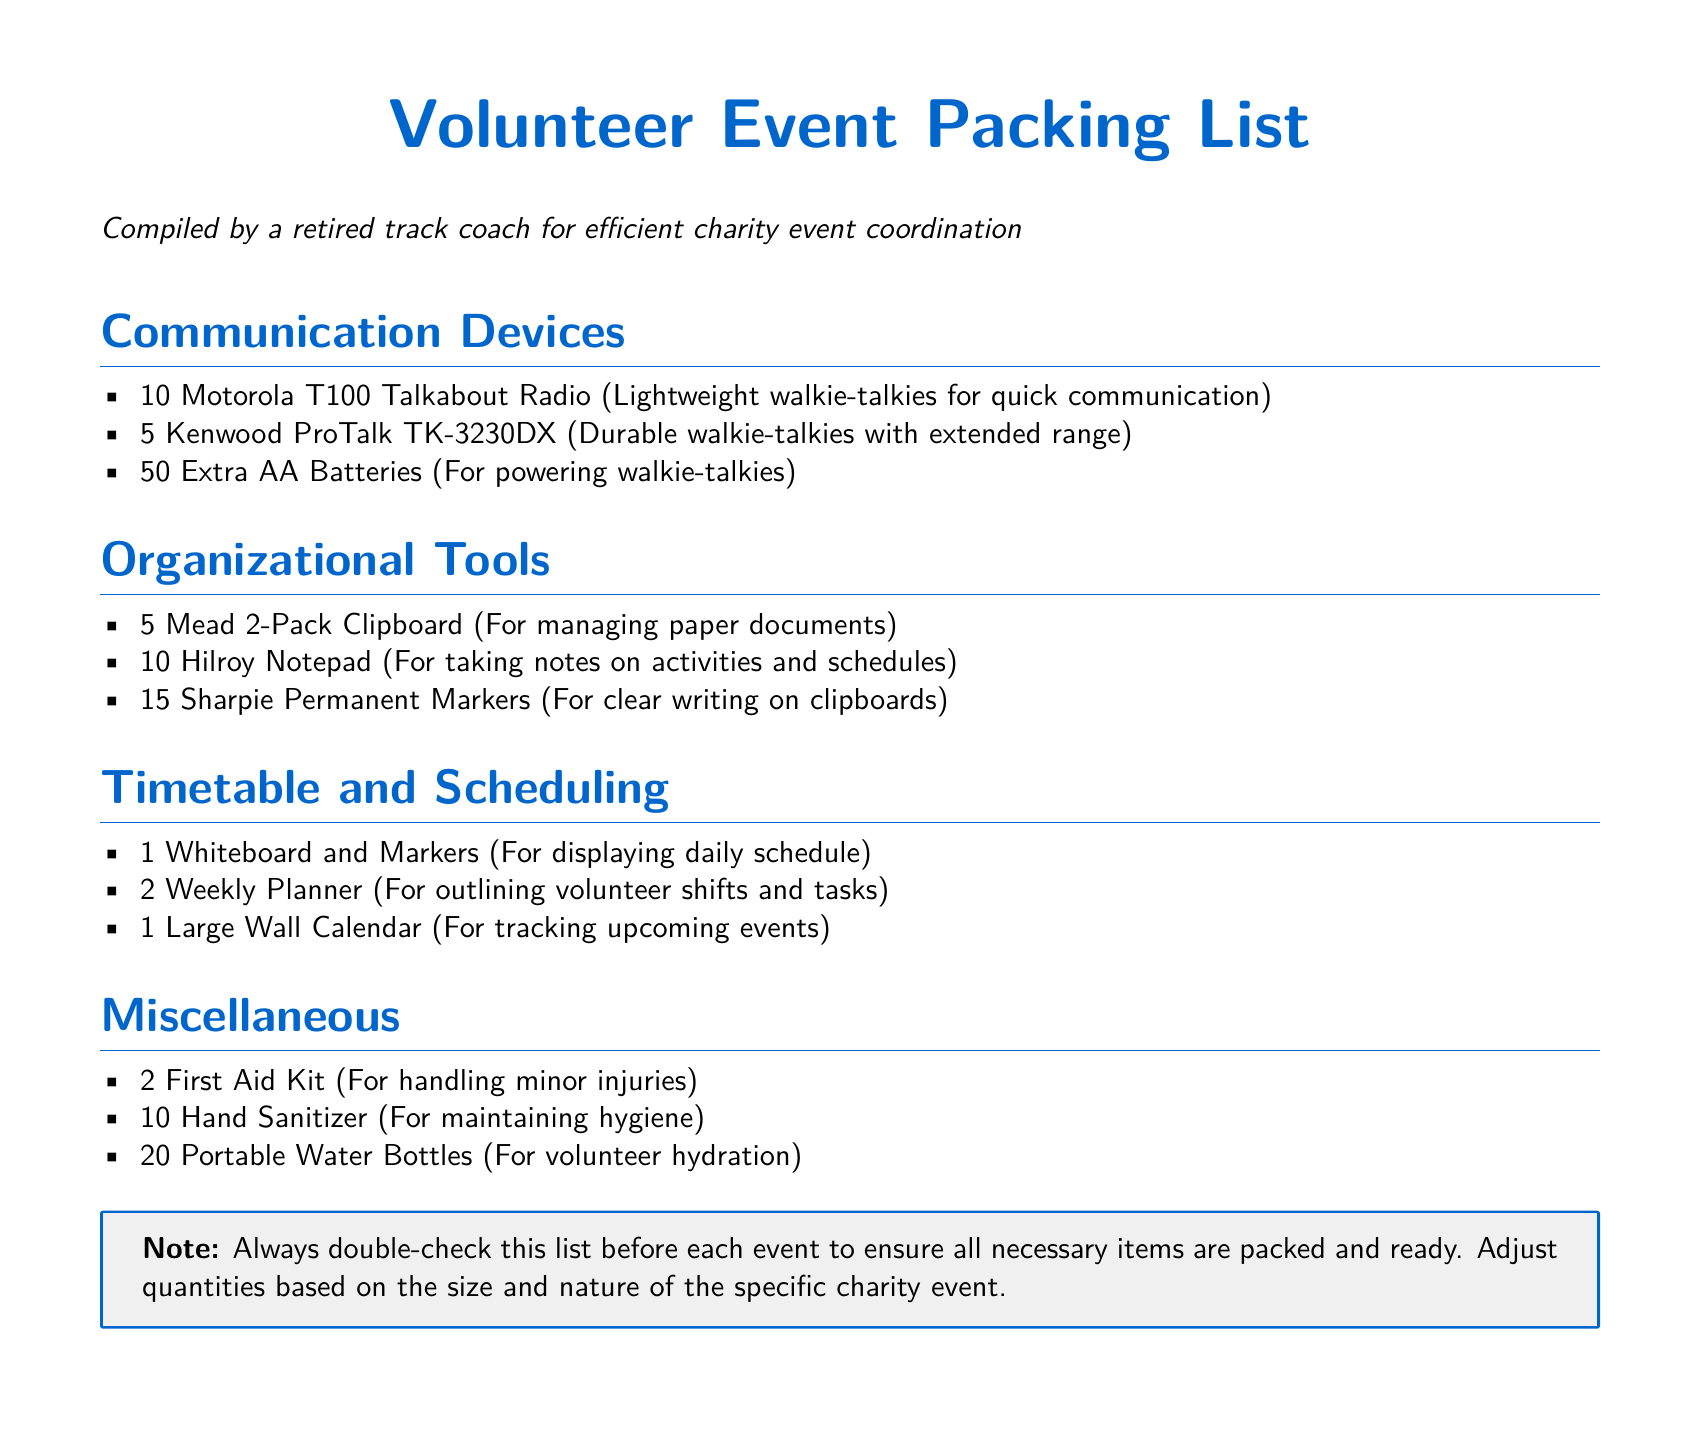what type of communication devices are listed? The document lists a variety of communication devices, including walkie-talkies.
Answer: walkie-talkies how many Kenwood ProTalk TK-3230DX are included in the list? The document specifies the quantity of Kenwood ProTalk TK-3230DX walkie-talkies provided.
Answer: 5 what item is used for managing paper documents? The document identifies a specific item that helps in managing paper documents.
Answer: Clipboard how many extra AA batteries are included? The document states the quantity of extra AA batteries provided for powering walkie-talkies.
Answer: 50 what is the total number of portable water bottles included? The document notes the total number of portable water bottles included in the packing list.
Answer: 20 which item is listed under Timetable and Scheduling? The document features specific items under the Timetable and Scheduling section.
Answer: Whiteboard and Markers how many Sharpie Permanent Markers are listed? The document indicates the quantity of Sharpie Permanent Markers included in the packing list.
Answer: 15 what is the purpose of the First Aid Kit? The document mentions the use of the First Aid Kit in preparation for volunteer events.
Answer: handling minor injuries what note is included at the end of the document? The document contains a reminder note regarding checking the packing list before events.
Answer: Always double-check this list before each event 